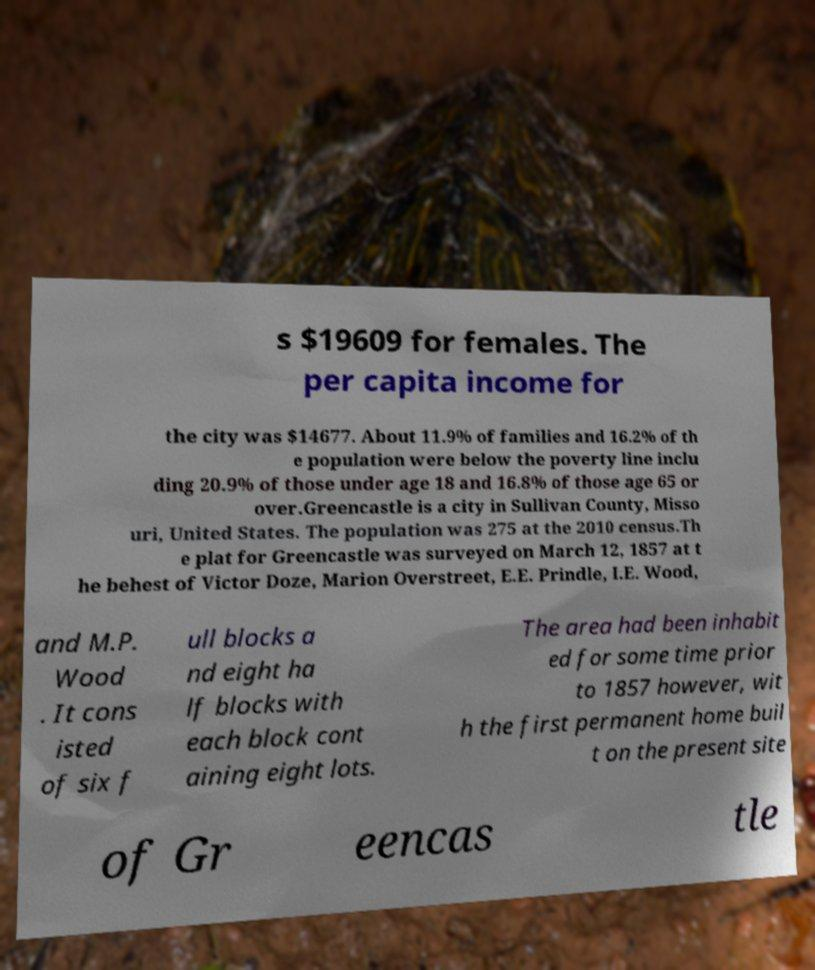There's text embedded in this image that I need extracted. Can you transcribe it verbatim? s $19609 for females. The per capita income for the city was $14677. About 11.9% of families and 16.2% of th e population were below the poverty line inclu ding 20.9% of those under age 18 and 16.8% of those age 65 or over.Greencastle is a city in Sullivan County, Misso uri, United States. The population was 275 at the 2010 census.Th e plat for Greencastle was surveyed on March 12, 1857 at t he behest of Victor Doze, Marion Overstreet, E.E. Prindle, I.E. Wood, and M.P. Wood . It cons isted of six f ull blocks a nd eight ha lf blocks with each block cont aining eight lots. The area had been inhabit ed for some time prior to 1857 however, wit h the first permanent home buil t on the present site of Gr eencas tle 